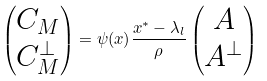Convert formula to latex. <formula><loc_0><loc_0><loc_500><loc_500>\begin{pmatrix} C _ { M } \\ C _ { M } ^ { \perp } \end{pmatrix} = \psi ( x ) \frac { x ^ { \ast } - \lambda _ { l } } { \rho } \begin{pmatrix} A \\ A ^ { \perp } \end{pmatrix}</formula> 